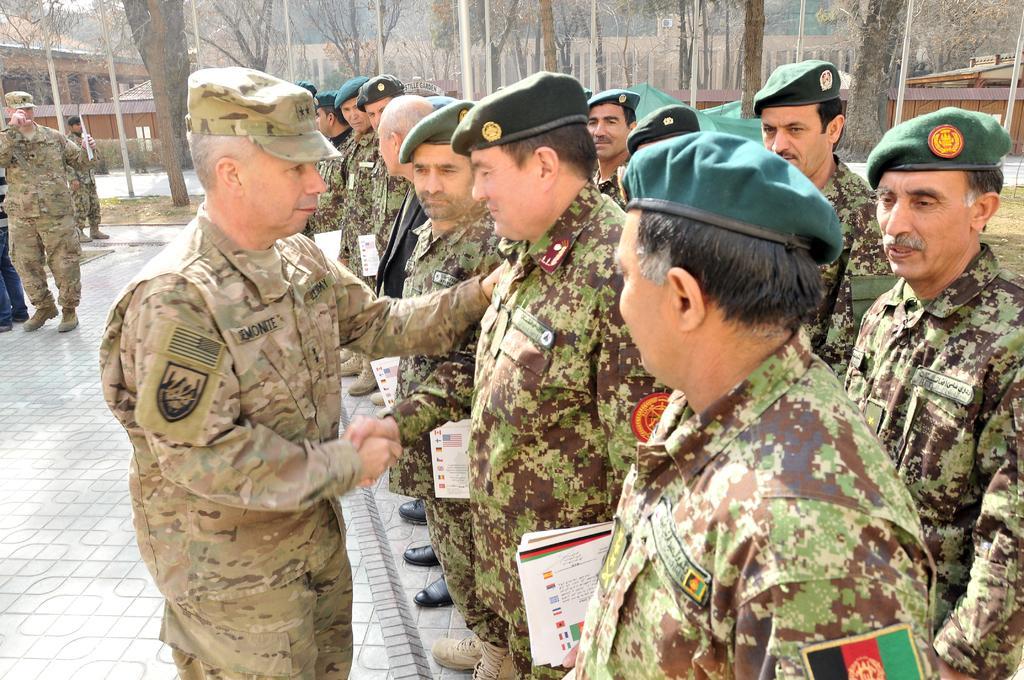In one or two sentences, can you explain what this image depicts? Here we can see group of people. In the background there are poles, trees, and houses. 